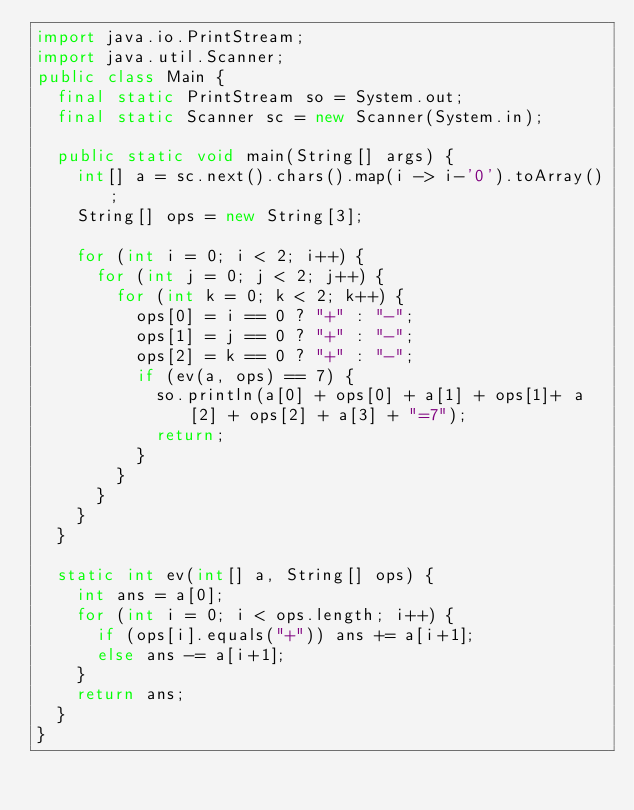Convert code to text. <code><loc_0><loc_0><loc_500><loc_500><_Java_>import java.io.PrintStream;
import java.util.Scanner;
public class Main {
	final static PrintStream so = System.out;
	final static Scanner sc = new Scanner(System.in);

	public static void main(String[] args) {
		int[] a = sc.next().chars().map(i -> i-'0').toArray();
		String[] ops = new String[3];
		
		for (int i = 0; i < 2; i++) {
			for (int j = 0; j < 2; j++) {
				for (int k = 0; k < 2; k++) {
					ops[0] = i == 0 ? "+" : "-";
					ops[1] = j == 0 ? "+" : "-";
					ops[2] = k == 0 ? "+" : "-";
					if (ev(a, ops) == 7) {
						so.println(a[0] + ops[0] + a[1] + ops[1]+ a[2] + ops[2] + a[3] + "=7");
						return;
					}
				}
			}
		}
	}
	
	static int ev(int[] a, String[] ops) {
		int ans = a[0];
		for (int i = 0; i < ops.length; i++) {
			if (ops[i].equals("+")) ans += a[i+1];
			else ans -= a[i+1];
		}
		return ans;
	}
}
</code> 